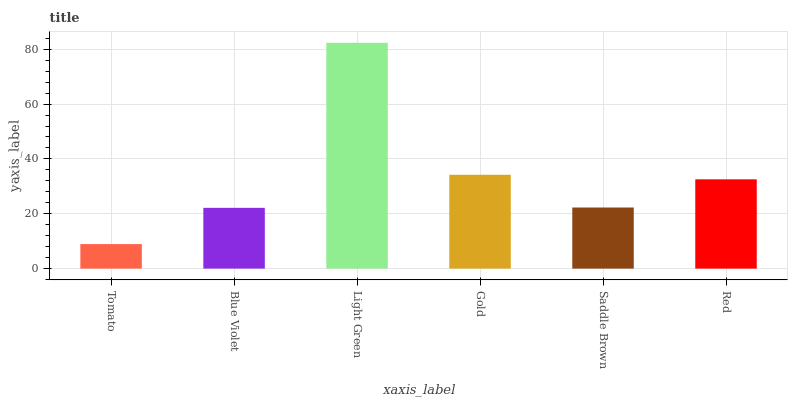Is Tomato the minimum?
Answer yes or no. Yes. Is Light Green the maximum?
Answer yes or no. Yes. Is Blue Violet the minimum?
Answer yes or no. No. Is Blue Violet the maximum?
Answer yes or no. No. Is Blue Violet greater than Tomato?
Answer yes or no. Yes. Is Tomato less than Blue Violet?
Answer yes or no. Yes. Is Tomato greater than Blue Violet?
Answer yes or no. No. Is Blue Violet less than Tomato?
Answer yes or no. No. Is Red the high median?
Answer yes or no. Yes. Is Saddle Brown the low median?
Answer yes or no. Yes. Is Gold the high median?
Answer yes or no. No. Is Tomato the low median?
Answer yes or no. No. 